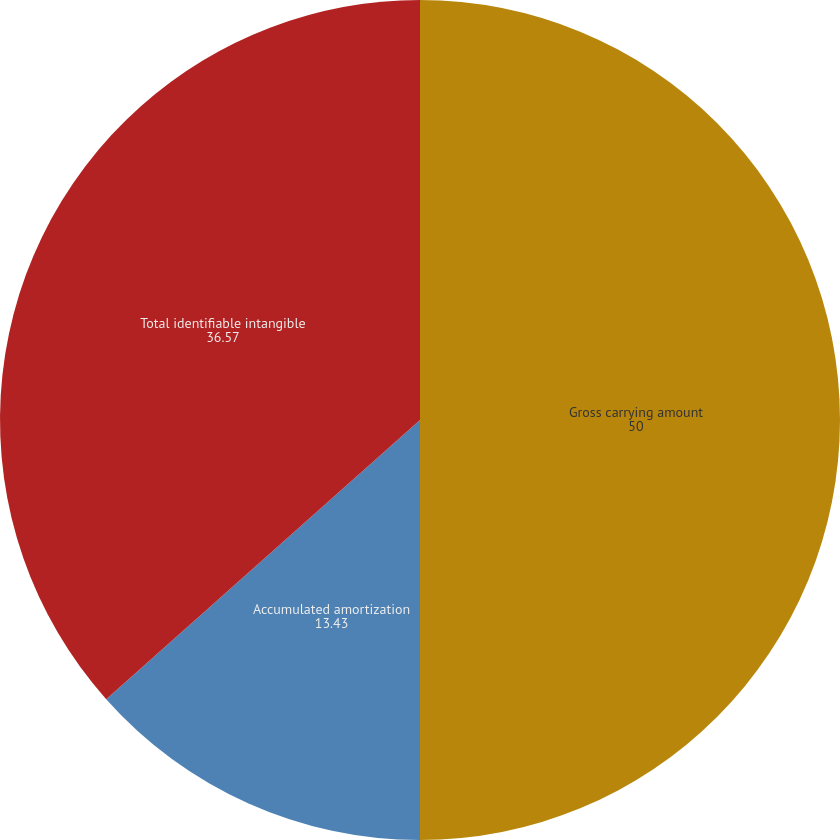Convert chart. <chart><loc_0><loc_0><loc_500><loc_500><pie_chart><fcel>Gross carrying amount<fcel>Accumulated amortization<fcel>Total identifiable intangible<nl><fcel>50.0%<fcel>13.43%<fcel>36.57%<nl></chart> 